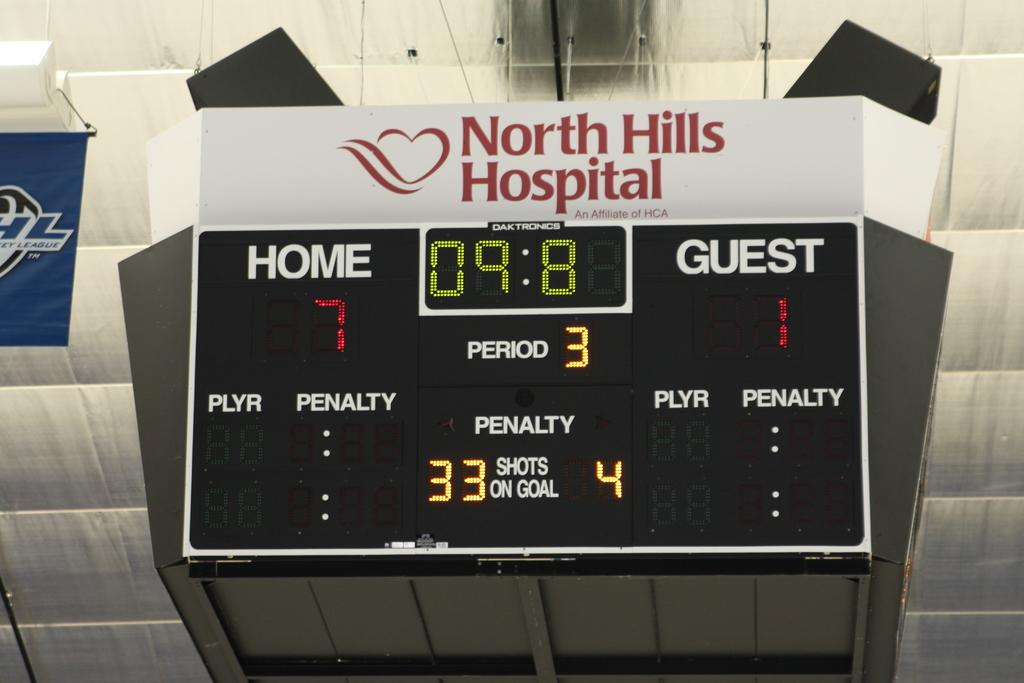Provide a one-sentence caption for the provided image. North Hills hospital sign is above a score board. 